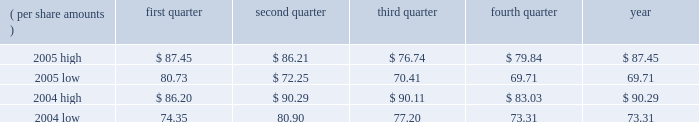Liabilities and related insurance receivables where applicable , or make such estimates for matters previously not susceptible of reasonable estimates , such as a significant judicial ruling or judgment , significant settlement , significant regulatory development or changes in applicable law .
A future adverse ruling , settlement or unfavorable development could result in future charges that could have a material adverse effect on the company 2019s results of operations or cash flows in any particular period .
A specific factor that could increase the company 2019s estimate of its future asbestos-related liabilities is the pending congressional consideration of legislation to reform asbestos- related litigation and pertinent information derived from that process .
For a more detailed discussion of the legal proceedings involving the company and associated accounting estimates , see the discussion in note 11 to the consolidated financial statements of this annual report on form 10-k .
Item 1b .
Unresolved staff comments .
Item 2 .
Properties .
3m 2019s general offices , corporate research laboratories , and certain division laboratories are located in st .
Paul , minnesota .
In the united states , 3m has 15 sales offices in 12 states and operates 59 manufacturing facilities in 23 states .
Internationally , 3m has 173 sales offices .
The company operates 80 manufacturing and converting facilities in 29 countries outside the united states .
3m owns substantially all of its physical properties .
3m 2019s physical facilities are highly suitable for the purposes for which they were designed .
Because 3m is a global enterprise characterized by substantial intersegment cooperation , properties are often used by multiple business segments .
Item 3 .
Legal proceedings .
Discussion of legal matters is incorporated by reference from part ii , item 8 , note 11 , 201ccommitments and contingencies 201d , of this document , and should be considered an integral part of part i , item 3 , 201clegal proceedings 201d .
Item 4 .
Submission of matters to a vote of security holders .
None in the quarter ended december 31 , 2005 .
Part ii item 5 .
Market for registrant 2019s common equity , related stockholder matters and issuer purchases of equity securities .
Equity compensation plans 2019 information is incorporated by reference from part iii , item 12 , security ownership of certain beneficial owners and management , of this document , and should be considered an integral part of item 5 .
At january 31 , 2006 , there were approximately 125823 shareholders of record .
3m 2019s stock is listed on the new york stock exchange , inc .
( nyse ) , pacific exchange , inc. , chicago stock exchange , inc. , and the swx swiss exchange .
Cash dividends declared and paid totaled $ .42 per share for each quarter of 2005 , and $ .36 per share for each quarter of 2004 .
Stock price comparisons follow : stock price comparisons ( nyse composite transactions ) ( per share amounts ) quarter second quarter quarter fourth quarter year .

In 2005 what was the quarterly dividend expense? 
Computations: (125823 * .42)
Answer: 52845.66. 